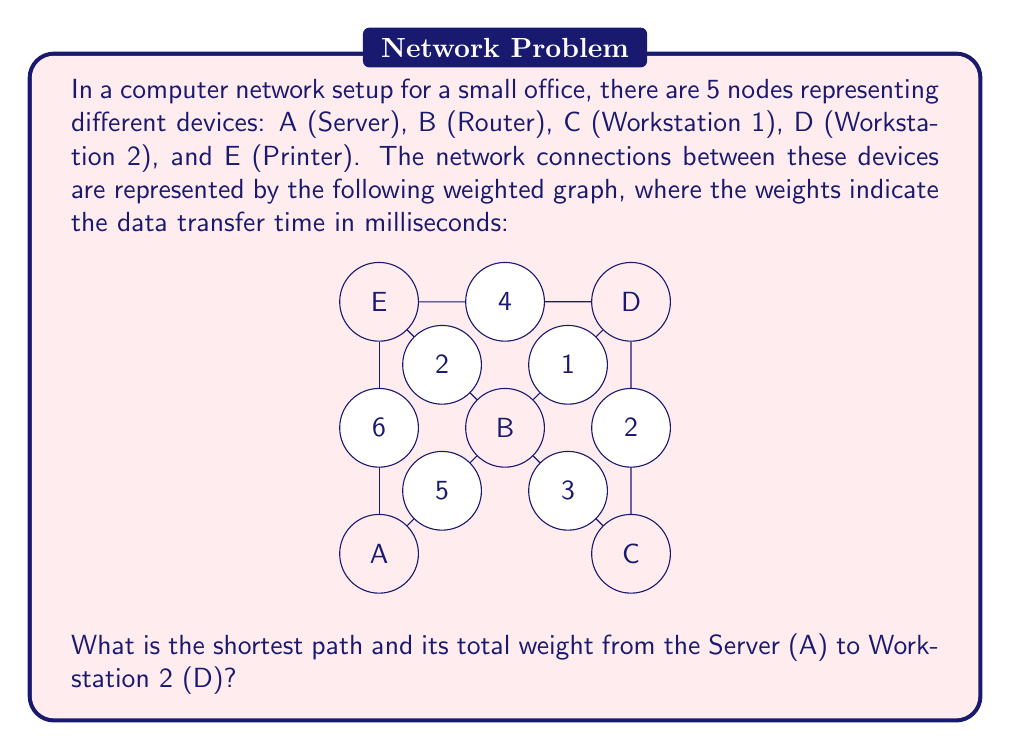Show me your answer to this math problem. To solve this problem, we can use Dijkstra's algorithm, which is an efficient method for finding the shortest path in a weighted graph. Let's apply the algorithm step by step:

1) Initialize:
   - Set distance to A as 0
   - Set distances to all other nodes as infinity
   - Set all nodes as unvisited

2) Start from node A:
   - Update distances to neighboring nodes:
     B: min(∞, 0 + 5) = 5
     E: min(∞, 0 + 6) = 6
   - Mark A as visited

3) Choose the unvisited node with the smallest distance (B):
   - Update distances to B's neighbors:
     C: min(∞, 5 + 3) = 8
     D: min(∞, 5 + 1) = 6
     E: min(6, 5 + 2) = 6 (no change)
   - Mark B as visited

4) Choose the unvisited node with the smallest distance (D or E, both 6):
   Let's choose D:
   - All of D's unvisited neighbors have been reached through shorter paths
   - Mark D as visited

5) The algorithm stops here as we've reached our destination (D)

The shortest path from A to D is: A → B → D
The total weight of this path is: 5 + 1 = 6 milliseconds
Answer: The shortest path from Server (A) to Workstation 2 (D) is A → B → D, with a total weight of 6 milliseconds. 